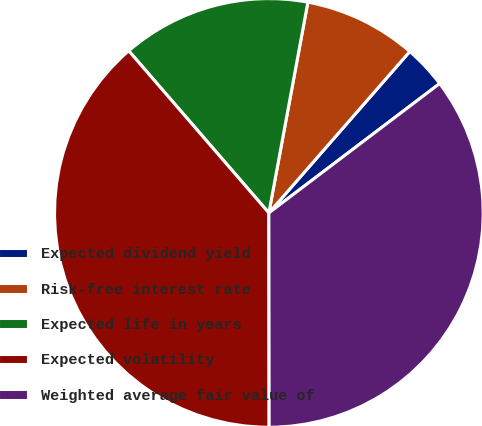<chart> <loc_0><loc_0><loc_500><loc_500><pie_chart><fcel>Expected dividend yield<fcel>Risk-free interest rate<fcel>Expected life in years<fcel>Expected volatility<fcel>Weighted average fair value of<nl><fcel>3.26%<fcel>8.51%<fcel>14.26%<fcel>38.68%<fcel>35.3%<nl></chart> 